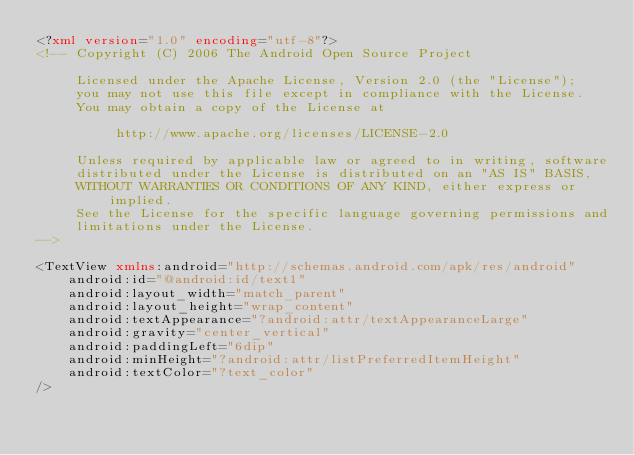Convert code to text. <code><loc_0><loc_0><loc_500><loc_500><_XML_><?xml version="1.0" encoding="utf-8"?>
<!-- Copyright (C) 2006 The Android Open Source Project

     Licensed under the Apache License, Version 2.0 (the "License");
     you may not use this file except in compliance with the License.
     You may obtain a copy of the License at
  
          http://www.apache.org/licenses/LICENSE-2.0
  
     Unless required by applicable law or agreed to in writing, software
     distributed under the License is distributed on an "AS IS" BASIS,
     WITHOUT WARRANTIES OR CONDITIONS OF ANY KIND, either express or implied.
     See the License for the specific language governing permissions and
     limitations under the License.
-->

<TextView xmlns:android="http://schemas.android.com/apk/res/android"
    android:id="@android:id/text1"
    android:layout_width="match_parent"
    android:layout_height="wrap_content"
    android:textAppearance="?android:attr/textAppearanceLarge"
    android:gravity="center_vertical"
    android:paddingLeft="6dip"
    android:minHeight="?android:attr/listPreferredItemHeight"
    android:textColor="?text_color"
/>
</code> 